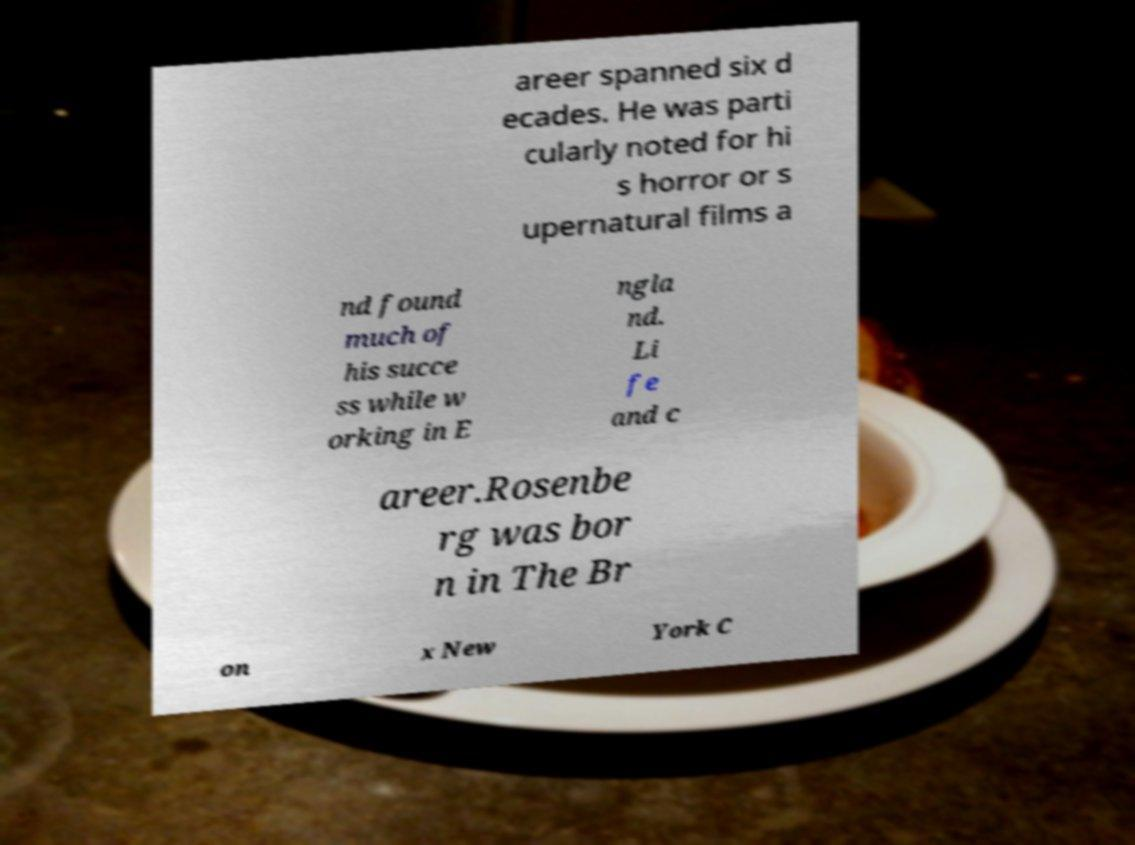Please read and relay the text visible in this image. What does it say? areer spanned six d ecades. He was parti cularly noted for hi s horror or s upernatural films a nd found much of his succe ss while w orking in E ngla nd. Li fe and c areer.Rosenbe rg was bor n in The Br on x New York C 